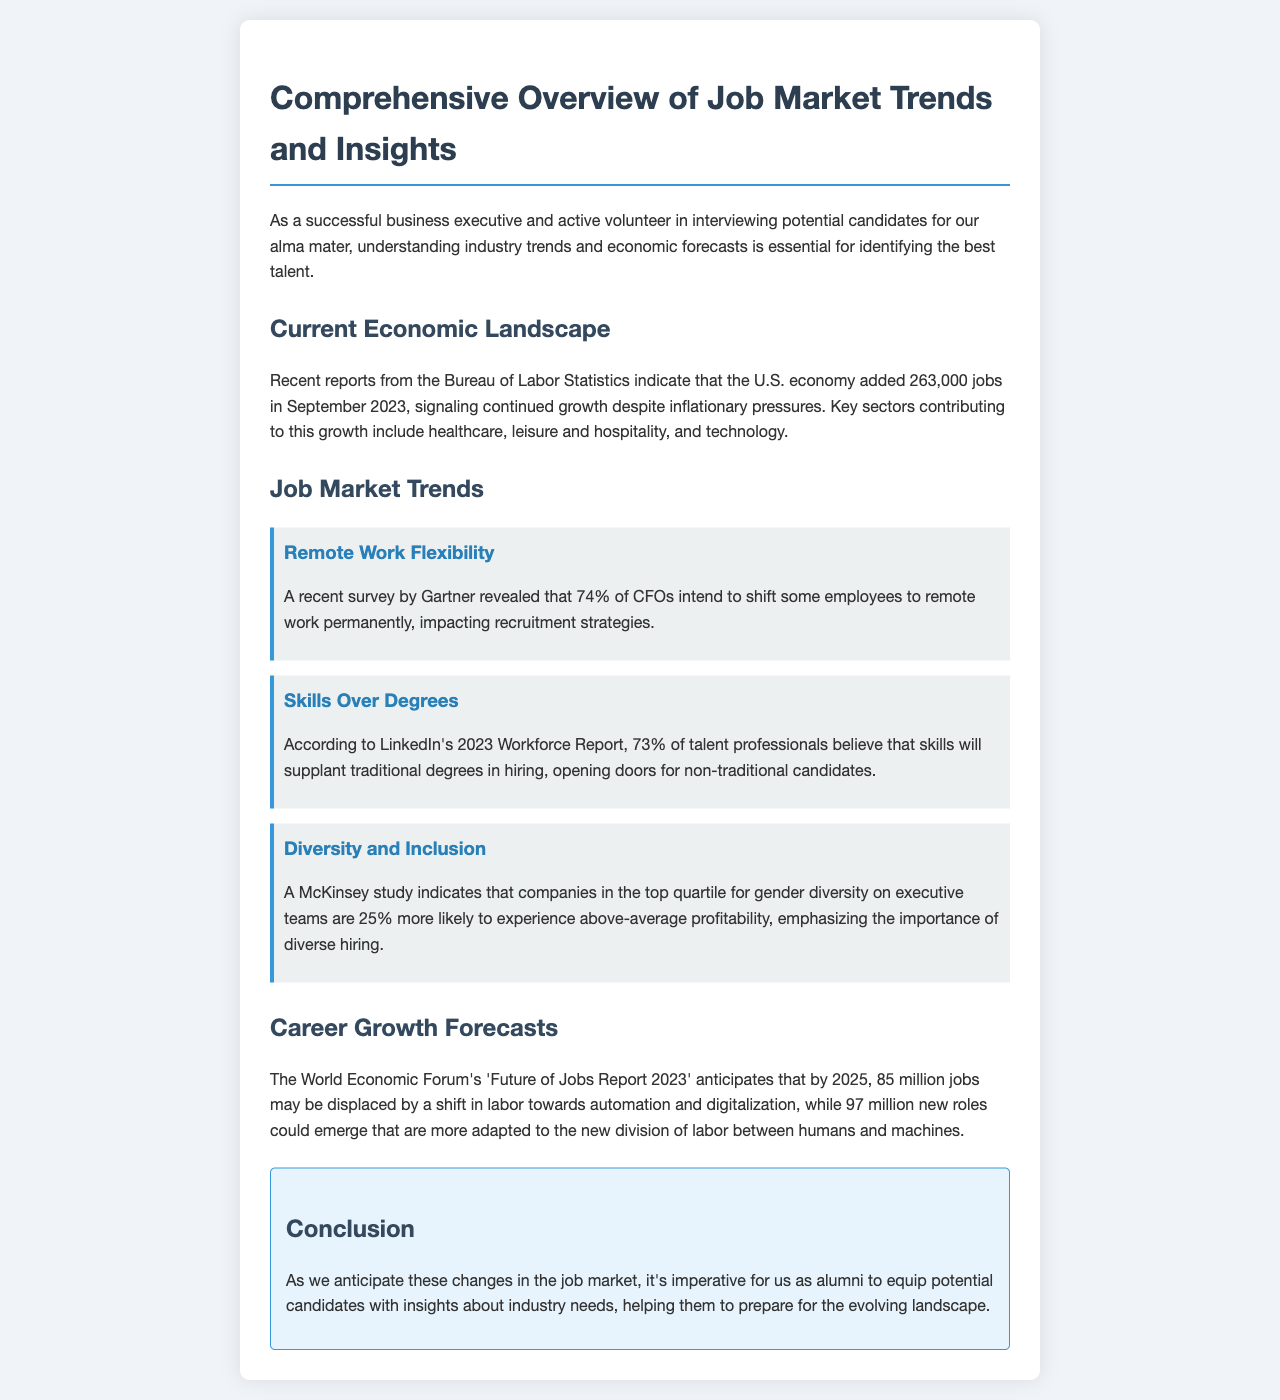What was the number of jobs added in September 2023? The document states that the U.S. economy added 263,000 jobs in September 2023, as indicated by the Bureau of Labor Statistics.
Answer: 263,000 Which sector is mentioned as contributing to job growth? The document specifies that key sectors contributing to job growth include healthcare, leisure and hospitality, and technology.
Answer: Healthcare, leisure and hospitality, technology What percentage of CFOs intend to shift employees to remote work permanently? According to a recent survey by Gartner, 74% of CFOs intend to shift some employees to remote work permanently.
Answer: 74% What do 73% of talent professionals believe regarding hiring? The document mentions that 73% of talent professionals believe that skills will supplant traditional degrees in hiring.
Answer: Skills will supplant traditional degrees How many million jobs may be displaced by 2025? The World Economic Forum’s report anticipates that 85 million jobs may be displaced by a shift in labor towards automation and digitalization by 2025.
Answer: 85 million What is the likelihood of companies with top quartile gender diversity experiencing profitability? A McKinsey study indicates that companies in the top quartile for gender diversity are 25% more likely to experience above-average profitability.
Answer: 25% What important factor should alumni equip potential candidates with? The document concludes that it's imperative for alumni to equip potential candidates with insights about industry needs.
Answer: Insights about industry needs What is the title of the document? The title of the document is prominently displayed at the top of the content.
Answer: Comprehensive Overview of Job Market Trends and Insights 